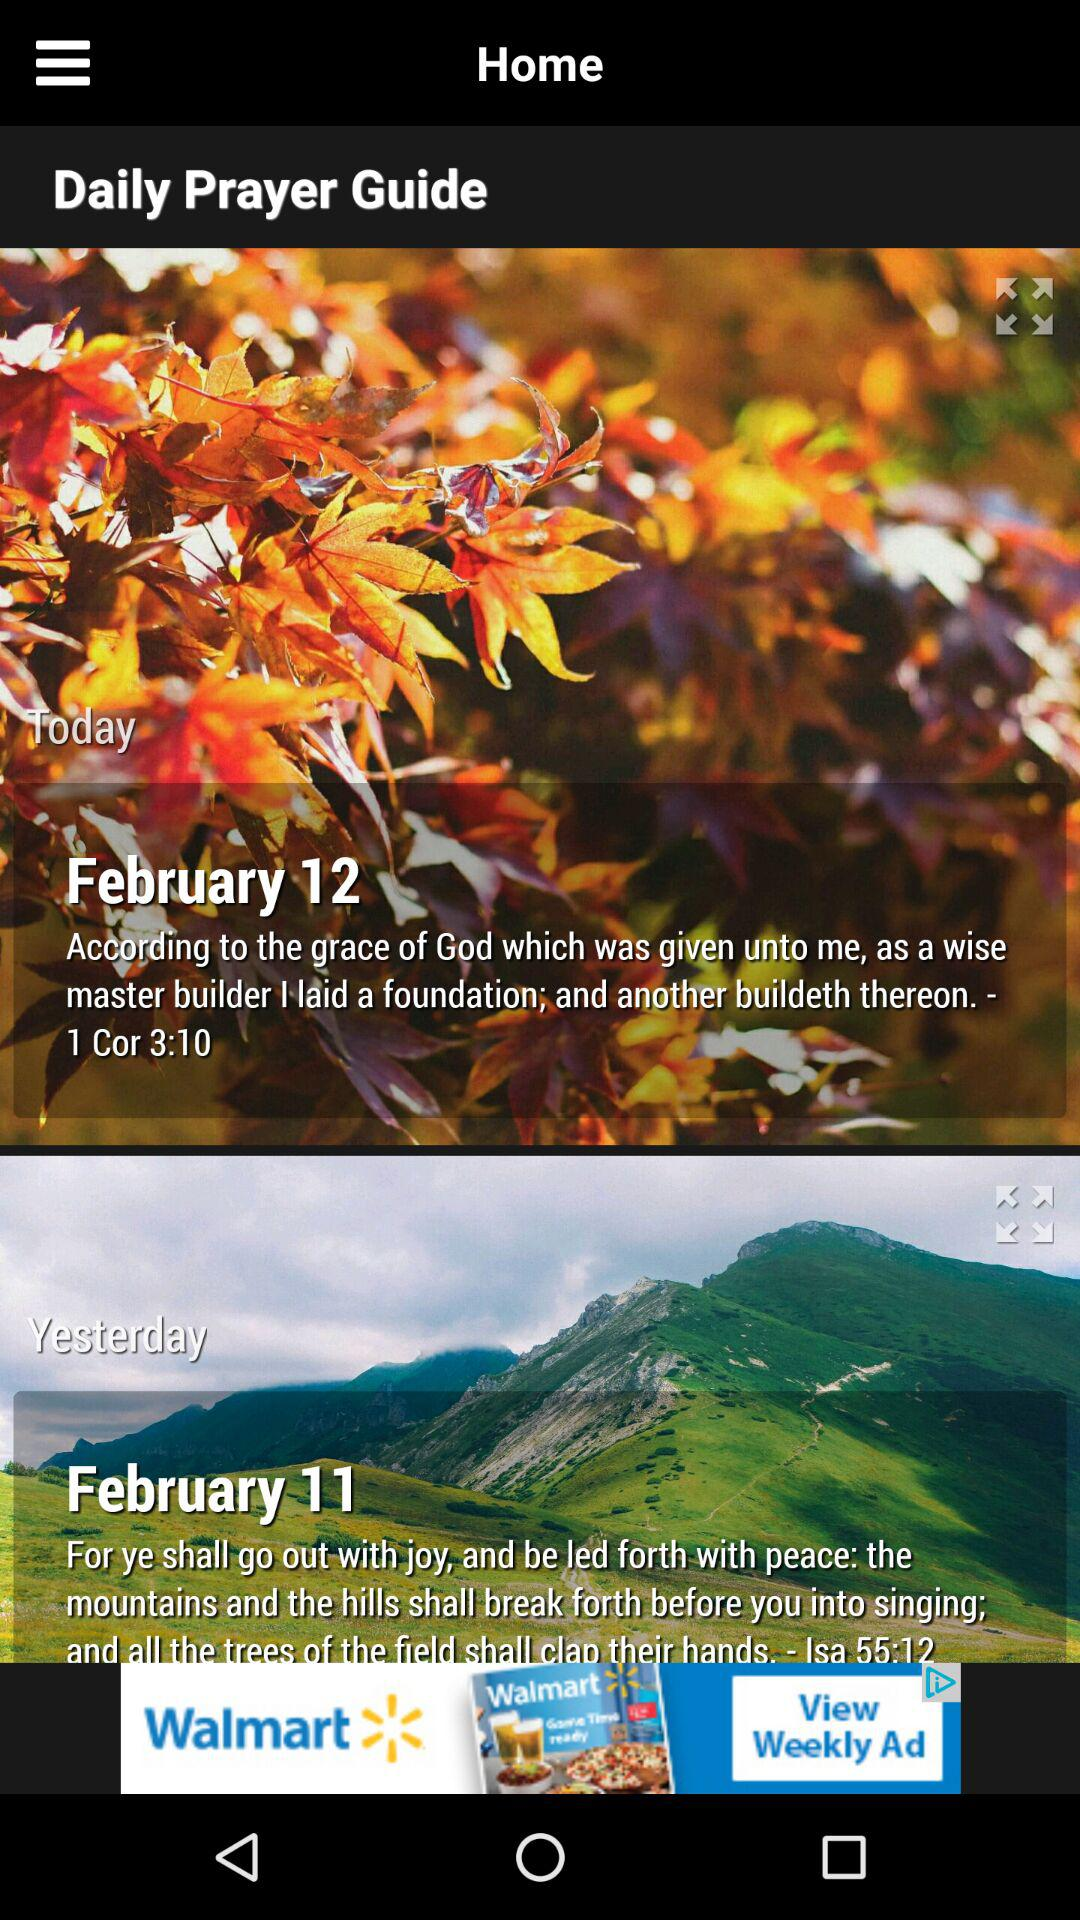How many days are displayed on this screen?
Answer the question using a single word or phrase. 2 